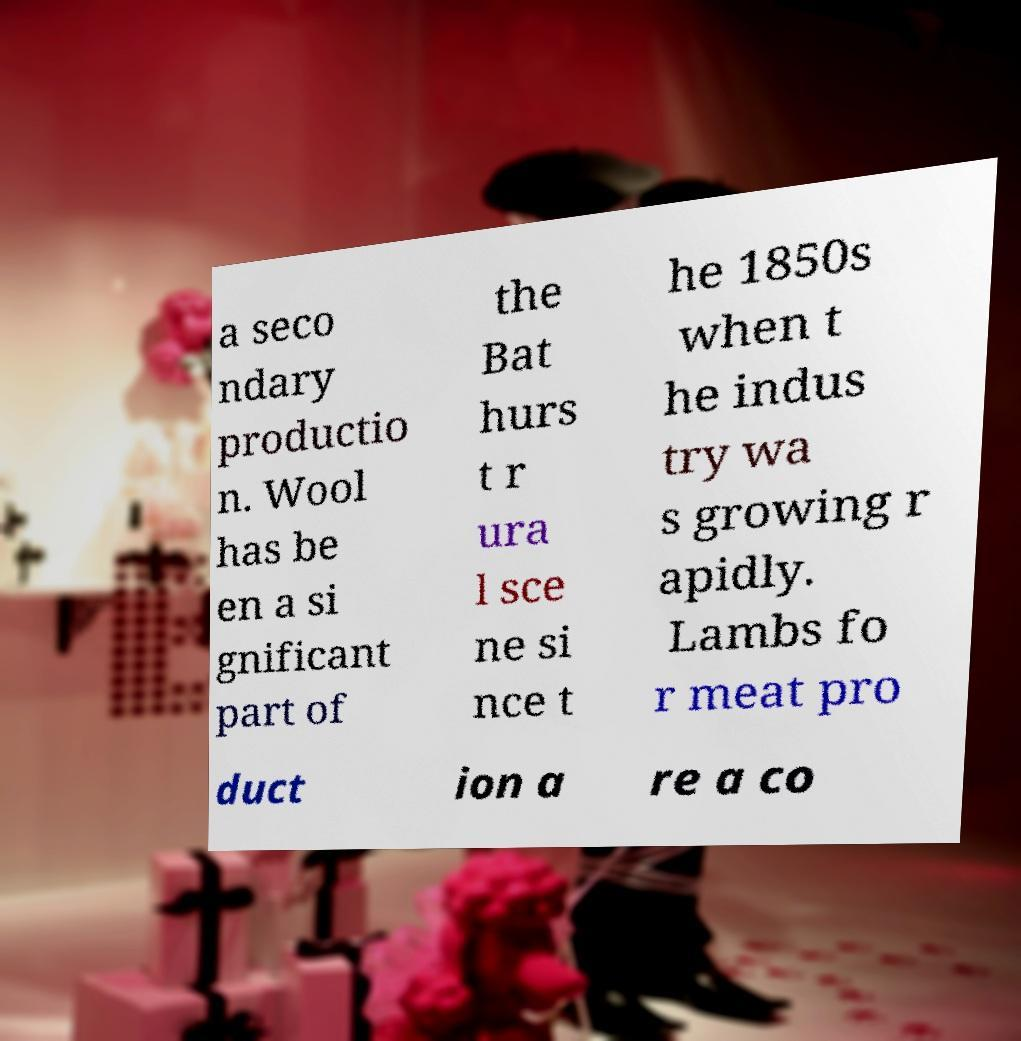I need the written content from this picture converted into text. Can you do that? a seco ndary productio n. Wool has be en a si gnificant part of the Bat hurs t r ura l sce ne si nce t he 1850s when t he indus try wa s growing r apidly. Lambs fo r meat pro duct ion a re a co 